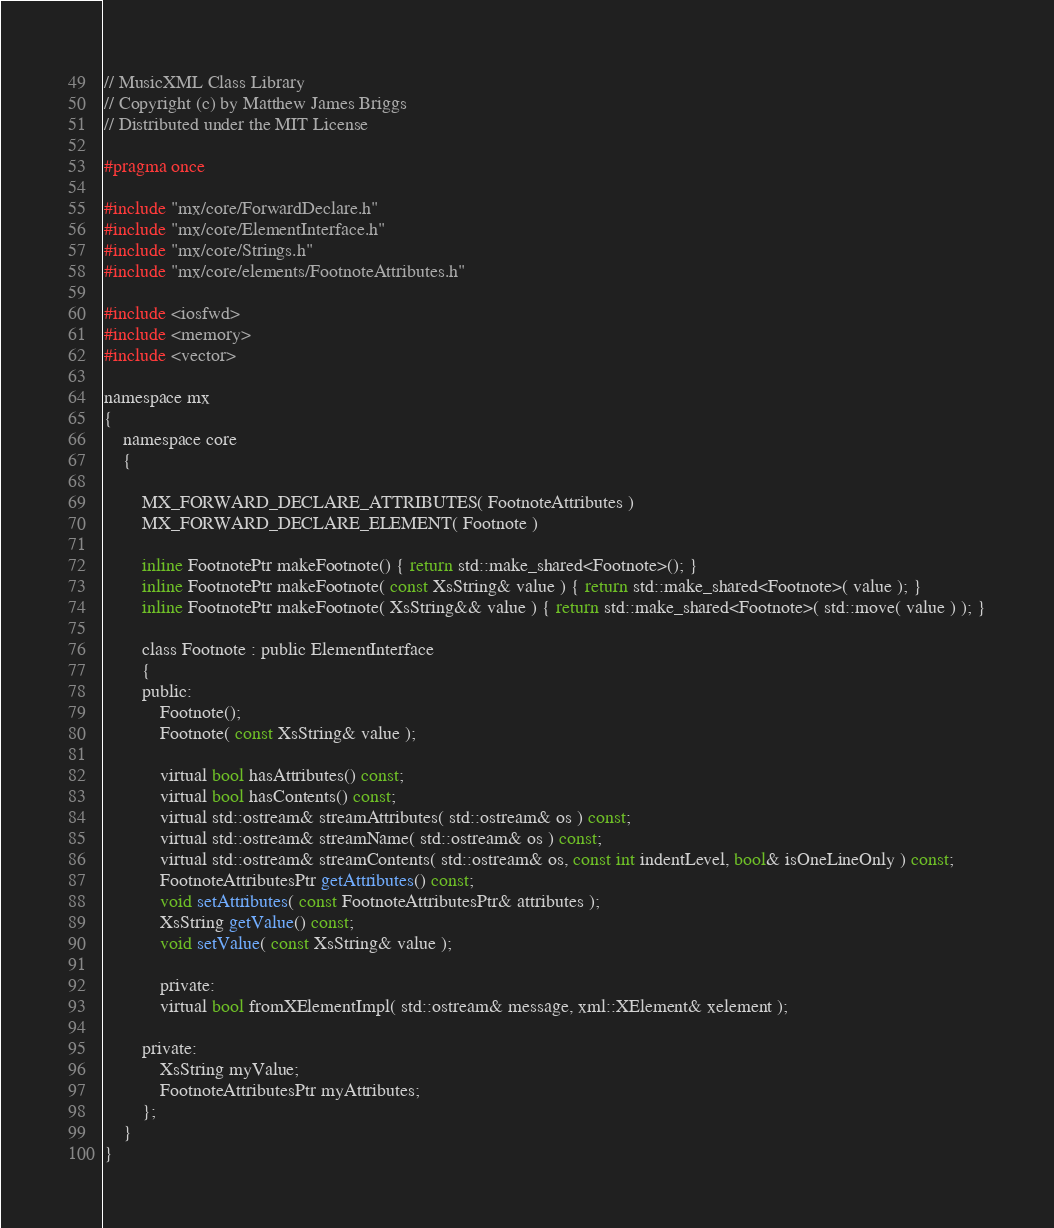Convert code to text. <code><loc_0><loc_0><loc_500><loc_500><_C_>// MusicXML Class Library
// Copyright (c) by Matthew James Briggs
// Distributed under the MIT License

#pragma once

#include "mx/core/ForwardDeclare.h"
#include "mx/core/ElementInterface.h"
#include "mx/core/Strings.h"
#include "mx/core/elements/FootnoteAttributes.h"

#include <iosfwd>
#include <memory>
#include <vector>

namespace mx
{
    namespace core
    {

        MX_FORWARD_DECLARE_ATTRIBUTES( FootnoteAttributes )
        MX_FORWARD_DECLARE_ELEMENT( Footnote )

        inline FootnotePtr makeFootnote() { return std::make_shared<Footnote>(); }
		inline FootnotePtr makeFootnote( const XsString& value ) { return std::make_shared<Footnote>( value ); }
		inline FootnotePtr makeFootnote( XsString&& value ) { return std::make_shared<Footnote>( std::move( value ) ); }

        class Footnote : public ElementInterface
        {
        public:
            Footnote();
            Footnote( const XsString& value );

            virtual bool hasAttributes() const;
            virtual bool hasContents() const;
            virtual std::ostream& streamAttributes( std::ostream& os ) const;
            virtual std::ostream& streamName( std::ostream& os ) const;
            virtual std::ostream& streamContents( std::ostream& os, const int indentLevel, bool& isOneLineOnly ) const;
            FootnoteAttributesPtr getAttributes() const;
            void setAttributes( const FootnoteAttributesPtr& attributes );
            XsString getValue() const;
            void setValue( const XsString& value );

            private:
            virtual bool fromXElementImpl( std::ostream& message, xml::XElement& xelement );

        private:
            XsString myValue;
            FootnoteAttributesPtr myAttributes;
        };
    }
}
</code> 